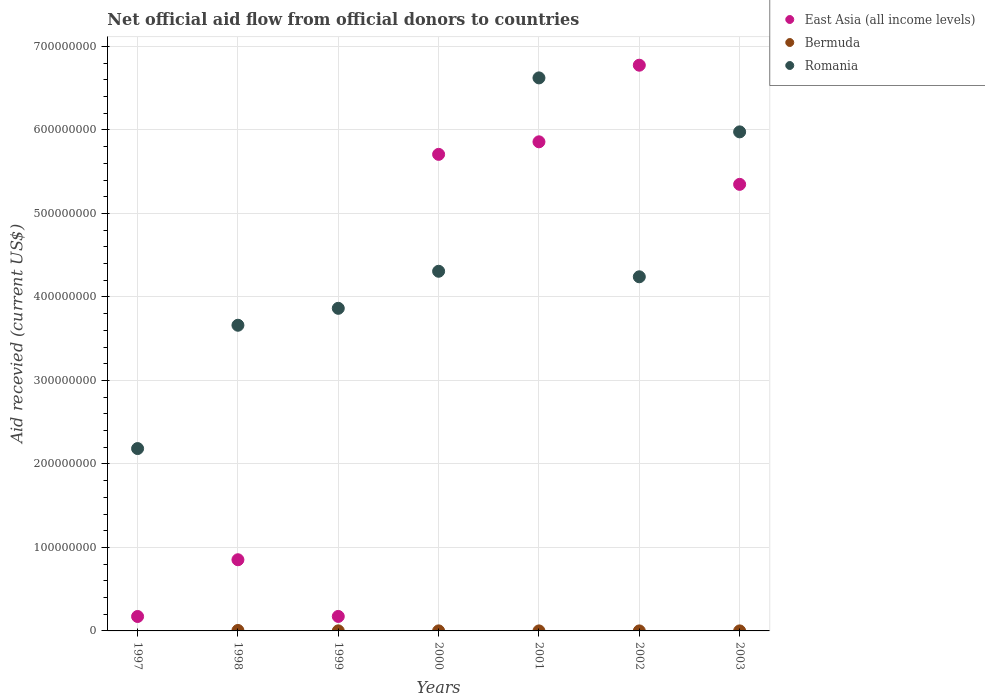Is the number of dotlines equal to the number of legend labels?
Give a very brief answer. No. What is the total aid received in Romania in 1999?
Make the answer very short. 3.86e+08. Across all years, what is the maximum total aid received in East Asia (all income levels)?
Ensure brevity in your answer.  6.78e+08. Across all years, what is the minimum total aid received in East Asia (all income levels)?
Your response must be concise. 1.73e+07. In which year was the total aid received in East Asia (all income levels) maximum?
Make the answer very short. 2002. What is the total total aid received in Romania in the graph?
Make the answer very short. 3.09e+09. What is the difference between the total aid received in Romania in 1999 and that in 2003?
Offer a terse response. -2.11e+08. What is the difference between the total aid received in Bermuda in 2003 and the total aid received in East Asia (all income levels) in 2000?
Provide a succinct answer. -5.71e+08. What is the average total aid received in East Asia (all income levels) per year?
Your answer should be very brief. 3.56e+08. In the year 2003, what is the difference between the total aid received in East Asia (all income levels) and total aid received in Romania?
Your answer should be compact. -6.29e+07. In how many years, is the total aid received in East Asia (all income levels) greater than 620000000 US$?
Make the answer very short. 1. What is the ratio of the total aid received in Romania in 1997 to that in 2000?
Offer a very short reply. 0.51. Is the difference between the total aid received in East Asia (all income levels) in 1999 and 2003 greater than the difference between the total aid received in Romania in 1999 and 2003?
Offer a terse response. No. What is the difference between the highest and the second highest total aid received in Romania?
Your answer should be compact. 6.46e+07. What is the difference between the highest and the lowest total aid received in Romania?
Make the answer very short. 4.44e+08. In how many years, is the total aid received in East Asia (all income levels) greater than the average total aid received in East Asia (all income levels) taken over all years?
Offer a very short reply. 4. Is the total aid received in Bermuda strictly greater than the total aid received in Romania over the years?
Offer a very short reply. No. How many dotlines are there?
Keep it short and to the point. 3. How many years are there in the graph?
Offer a terse response. 7. Are the values on the major ticks of Y-axis written in scientific E-notation?
Keep it short and to the point. No. Does the graph contain any zero values?
Offer a terse response. Yes. Does the graph contain grids?
Your response must be concise. Yes. Where does the legend appear in the graph?
Provide a succinct answer. Top right. How many legend labels are there?
Make the answer very short. 3. How are the legend labels stacked?
Your response must be concise. Vertical. What is the title of the graph?
Your answer should be very brief. Net official aid flow from official donors to countries. What is the label or title of the Y-axis?
Your answer should be compact. Aid recevied (current US$). What is the Aid recevied (current US$) of East Asia (all income levels) in 1997?
Make the answer very short. 1.73e+07. What is the Aid recevied (current US$) in Romania in 1997?
Offer a terse response. 2.18e+08. What is the Aid recevied (current US$) of East Asia (all income levels) in 1998?
Your answer should be very brief. 8.52e+07. What is the Aid recevied (current US$) of Bermuda in 1998?
Keep it short and to the point. 5.50e+05. What is the Aid recevied (current US$) in Romania in 1998?
Give a very brief answer. 3.66e+08. What is the Aid recevied (current US$) in East Asia (all income levels) in 1999?
Offer a very short reply. 1.74e+07. What is the Aid recevied (current US$) of Bermuda in 1999?
Keep it short and to the point. 8.00e+04. What is the Aid recevied (current US$) in Romania in 1999?
Offer a terse response. 3.86e+08. What is the Aid recevied (current US$) of East Asia (all income levels) in 2000?
Make the answer very short. 5.71e+08. What is the Aid recevied (current US$) of Bermuda in 2000?
Make the answer very short. 6.00e+04. What is the Aid recevied (current US$) of Romania in 2000?
Provide a short and direct response. 4.31e+08. What is the Aid recevied (current US$) of East Asia (all income levels) in 2001?
Ensure brevity in your answer.  5.86e+08. What is the Aid recevied (current US$) in Bermuda in 2001?
Provide a succinct answer. 2.00e+04. What is the Aid recevied (current US$) in Romania in 2001?
Give a very brief answer. 6.62e+08. What is the Aid recevied (current US$) in East Asia (all income levels) in 2002?
Offer a terse response. 6.78e+08. What is the Aid recevied (current US$) in Bermuda in 2002?
Your answer should be compact. 2.00e+04. What is the Aid recevied (current US$) in Romania in 2002?
Provide a succinct answer. 4.24e+08. What is the Aid recevied (current US$) of East Asia (all income levels) in 2003?
Make the answer very short. 5.35e+08. What is the Aid recevied (current US$) in Bermuda in 2003?
Your answer should be very brief. 3.00e+04. What is the Aid recevied (current US$) of Romania in 2003?
Keep it short and to the point. 5.98e+08. Across all years, what is the maximum Aid recevied (current US$) of East Asia (all income levels)?
Provide a succinct answer. 6.78e+08. Across all years, what is the maximum Aid recevied (current US$) in Romania?
Give a very brief answer. 6.62e+08. Across all years, what is the minimum Aid recevied (current US$) in East Asia (all income levels)?
Your answer should be very brief. 1.73e+07. Across all years, what is the minimum Aid recevied (current US$) in Bermuda?
Your answer should be very brief. 0. Across all years, what is the minimum Aid recevied (current US$) of Romania?
Your answer should be very brief. 2.18e+08. What is the total Aid recevied (current US$) in East Asia (all income levels) in the graph?
Give a very brief answer. 2.49e+09. What is the total Aid recevied (current US$) in Bermuda in the graph?
Offer a very short reply. 7.60e+05. What is the total Aid recevied (current US$) in Romania in the graph?
Keep it short and to the point. 3.09e+09. What is the difference between the Aid recevied (current US$) in East Asia (all income levels) in 1997 and that in 1998?
Provide a succinct answer. -6.80e+07. What is the difference between the Aid recevied (current US$) of Romania in 1997 and that in 1998?
Provide a short and direct response. -1.48e+08. What is the difference between the Aid recevied (current US$) of East Asia (all income levels) in 1997 and that in 1999?
Offer a terse response. -6.00e+04. What is the difference between the Aid recevied (current US$) of Romania in 1997 and that in 1999?
Offer a very short reply. -1.68e+08. What is the difference between the Aid recevied (current US$) in East Asia (all income levels) in 1997 and that in 2000?
Your answer should be very brief. -5.54e+08. What is the difference between the Aid recevied (current US$) in Romania in 1997 and that in 2000?
Give a very brief answer. -2.12e+08. What is the difference between the Aid recevied (current US$) in East Asia (all income levels) in 1997 and that in 2001?
Your response must be concise. -5.69e+08. What is the difference between the Aid recevied (current US$) in Romania in 1997 and that in 2001?
Offer a terse response. -4.44e+08. What is the difference between the Aid recevied (current US$) in East Asia (all income levels) in 1997 and that in 2002?
Keep it short and to the point. -6.60e+08. What is the difference between the Aid recevied (current US$) in Romania in 1997 and that in 2002?
Provide a short and direct response. -2.06e+08. What is the difference between the Aid recevied (current US$) of East Asia (all income levels) in 1997 and that in 2003?
Your response must be concise. -5.18e+08. What is the difference between the Aid recevied (current US$) of Romania in 1997 and that in 2003?
Offer a terse response. -3.79e+08. What is the difference between the Aid recevied (current US$) of East Asia (all income levels) in 1998 and that in 1999?
Provide a short and direct response. 6.79e+07. What is the difference between the Aid recevied (current US$) of Romania in 1998 and that in 1999?
Give a very brief answer. -2.03e+07. What is the difference between the Aid recevied (current US$) of East Asia (all income levels) in 1998 and that in 2000?
Make the answer very short. -4.86e+08. What is the difference between the Aid recevied (current US$) in Bermuda in 1998 and that in 2000?
Offer a terse response. 4.90e+05. What is the difference between the Aid recevied (current US$) of Romania in 1998 and that in 2000?
Ensure brevity in your answer.  -6.46e+07. What is the difference between the Aid recevied (current US$) of East Asia (all income levels) in 1998 and that in 2001?
Ensure brevity in your answer.  -5.01e+08. What is the difference between the Aid recevied (current US$) of Bermuda in 1998 and that in 2001?
Your answer should be very brief. 5.30e+05. What is the difference between the Aid recevied (current US$) in Romania in 1998 and that in 2001?
Offer a terse response. -2.96e+08. What is the difference between the Aid recevied (current US$) of East Asia (all income levels) in 1998 and that in 2002?
Ensure brevity in your answer.  -5.92e+08. What is the difference between the Aid recevied (current US$) in Bermuda in 1998 and that in 2002?
Provide a succinct answer. 5.30e+05. What is the difference between the Aid recevied (current US$) of Romania in 1998 and that in 2002?
Make the answer very short. -5.80e+07. What is the difference between the Aid recevied (current US$) in East Asia (all income levels) in 1998 and that in 2003?
Your response must be concise. -4.50e+08. What is the difference between the Aid recevied (current US$) in Bermuda in 1998 and that in 2003?
Offer a terse response. 5.20e+05. What is the difference between the Aid recevied (current US$) in Romania in 1998 and that in 2003?
Provide a succinct answer. -2.32e+08. What is the difference between the Aid recevied (current US$) of East Asia (all income levels) in 1999 and that in 2000?
Keep it short and to the point. -5.53e+08. What is the difference between the Aid recevied (current US$) in Romania in 1999 and that in 2000?
Ensure brevity in your answer.  -4.44e+07. What is the difference between the Aid recevied (current US$) of East Asia (all income levels) in 1999 and that in 2001?
Your response must be concise. -5.68e+08. What is the difference between the Aid recevied (current US$) of Bermuda in 1999 and that in 2001?
Your answer should be compact. 6.00e+04. What is the difference between the Aid recevied (current US$) in Romania in 1999 and that in 2001?
Your answer should be very brief. -2.76e+08. What is the difference between the Aid recevied (current US$) in East Asia (all income levels) in 1999 and that in 2002?
Your response must be concise. -6.60e+08. What is the difference between the Aid recevied (current US$) of Romania in 1999 and that in 2002?
Provide a succinct answer. -3.78e+07. What is the difference between the Aid recevied (current US$) in East Asia (all income levels) in 1999 and that in 2003?
Offer a very short reply. -5.18e+08. What is the difference between the Aid recevied (current US$) in Bermuda in 1999 and that in 2003?
Your answer should be compact. 5.00e+04. What is the difference between the Aid recevied (current US$) of Romania in 1999 and that in 2003?
Provide a succinct answer. -2.11e+08. What is the difference between the Aid recevied (current US$) in East Asia (all income levels) in 2000 and that in 2001?
Provide a short and direct response. -1.50e+07. What is the difference between the Aid recevied (current US$) of Bermuda in 2000 and that in 2001?
Ensure brevity in your answer.  4.00e+04. What is the difference between the Aid recevied (current US$) of Romania in 2000 and that in 2001?
Keep it short and to the point. -2.32e+08. What is the difference between the Aid recevied (current US$) of East Asia (all income levels) in 2000 and that in 2002?
Offer a very short reply. -1.07e+08. What is the difference between the Aid recevied (current US$) of Romania in 2000 and that in 2002?
Provide a succinct answer. 6.62e+06. What is the difference between the Aid recevied (current US$) of East Asia (all income levels) in 2000 and that in 2003?
Ensure brevity in your answer.  3.59e+07. What is the difference between the Aid recevied (current US$) in Bermuda in 2000 and that in 2003?
Make the answer very short. 3.00e+04. What is the difference between the Aid recevied (current US$) in Romania in 2000 and that in 2003?
Your response must be concise. -1.67e+08. What is the difference between the Aid recevied (current US$) in East Asia (all income levels) in 2001 and that in 2002?
Your answer should be very brief. -9.18e+07. What is the difference between the Aid recevied (current US$) in Bermuda in 2001 and that in 2002?
Provide a short and direct response. 0. What is the difference between the Aid recevied (current US$) in Romania in 2001 and that in 2002?
Your answer should be very brief. 2.38e+08. What is the difference between the Aid recevied (current US$) of East Asia (all income levels) in 2001 and that in 2003?
Give a very brief answer. 5.10e+07. What is the difference between the Aid recevied (current US$) in Bermuda in 2001 and that in 2003?
Your answer should be compact. -10000. What is the difference between the Aid recevied (current US$) in Romania in 2001 and that in 2003?
Your answer should be compact. 6.46e+07. What is the difference between the Aid recevied (current US$) of East Asia (all income levels) in 2002 and that in 2003?
Offer a terse response. 1.43e+08. What is the difference between the Aid recevied (current US$) in Romania in 2002 and that in 2003?
Provide a succinct answer. -1.74e+08. What is the difference between the Aid recevied (current US$) of East Asia (all income levels) in 1997 and the Aid recevied (current US$) of Bermuda in 1998?
Make the answer very short. 1.67e+07. What is the difference between the Aid recevied (current US$) in East Asia (all income levels) in 1997 and the Aid recevied (current US$) in Romania in 1998?
Your response must be concise. -3.49e+08. What is the difference between the Aid recevied (current US$) of East Asia (all income levels) in 1997 and the Aid recevied (current US$) of Bermuda in 1999?
Your answer should be very brief. 1.72e+07. What is the difference between the Aid recevied (current US$) in East Asia (all income levels) in 1997 and the Aid recevied (current US$) in Romania in 1999?
Make the answer very short. -3.69e+08. What is the difference between the Aid recevied (current US$) of East Asia (all income levels) in 1997 and the Aid recevied (current US$) of Bermuda in 2000?
Ensure brevity in your answer.  1.72e+07. What is the difference between the Aid recevied (current US$) in East Asia (all income levels) in 1997 and the Aid recevied (current US$) in Romania in 2000?
Your response must be concise. -4.13e+08. What is the difference between the Aid recevied (current US$) of East Asia (all income levels) in 1997 and the Aid recevied (current US$) of Bermuda in 2001?
Offer a terse response. 1.73e+07. What is the difference between the Aid recevied (current US$) of East Asia (all income levels) in 1997 and the Aid recevied (current US$) of Romania in 2001?
Your response must be concise. -6.45e+08. What is the difference between the Aid recevied (current US$) in East Asia (all income levels) in 1997 and the Aid recevied (current US$) in Bermuda in 2002?
Provide a short and direct response. 1.73e+07. What is the difference between the Aid recevied (current US$) in East Asia (all income levels) in 1997 and the Aid recevied (current US$) in Romania in 2002?
Your answer should be very brief. -4.07e+08. What is the difference between the Aid recevied (current US$) of East Asia (all income levels) in 1997 and the Aid recevied (current US$) of Bermuda in 2003?
Your answer should be very brief. 1.73e+07. What is the difference between the Aid recevied (current US$) of East Asia (all income levels) in 1997 and the Aid recevied (current US$) of Romania in 2003?
Your answer should be very brief. -5.80e+08. What is the difference between the Aid recevied (current US$) in East Asia (all income levels) in 1998 and the Aid recevied (current US$) in Bermuda in 1999?
Keep it short and to the point. 8.52e+07. What is the difference between the Aid recevied (current US$) of East Asia (all income levels) in 1998 and the Aid recevied (current US$) of Romania in 1999?
Provide a short and direct response. -3.01e+08. What is the difference between the Aid recevied (current US$) in Bermuda in 1998 and the Aid recevied (current US$) in Romania in 1999?
Ensure brevity in your answer.  -3.86e+08. What is the difference between the Aid recevied (current US$) in East Asia (all income levels) in 1998 and the Aid recevied (current US$) in Bermuda in 2000?
Offer a terse response. 8.52e+07. What is the difference between the Aid recevied (current US$) of East Asia (all income levels) in 1998 and the Aid recevied (current US$) of Romania in 2000?
Give a very brief answer. -3.46e+08. What is the difference between the Aid recevied (current US$) of Bermuda in 1998 and the Aid recevied (current US$) of Romania in 2000?
Keep it short and to the point. -4.30e+08. What is the difference between the Aid recevied (current US$) of East Asia (all income levels) in 1998 and the Aid recevied (current US$) of Bermuda in 2001?
Give a very brief answer. 8.52e+07. What is the difference between the Aid recevied (current US$) in East Asia (all income levels) in 1998 and the Aid recevied (current US$) in Romania in 2001?
Make the answer very short. -5.77e+08. What is the difference between the Aid recevied (current US$) of Bermuda in 1998 and the Aid recevied (current US$) of Romania in 2001?
Keep it short and to the point. -6.62e+08. What is the difference between the Aid recevied (current US$) of East Asia (all income levels) in 1998 and the Aid recevied (current US$) of Bermuda in 2002?
Offer a very short reply. 8.52e+07. What is the difference between the Aid recevied (current US$) of East Asia (all income levels) in 1998 and the Aid recevied (current US$) of Romania in 2002?
Keep it short and to the point. -3.39e+08. What is the difference between the Aid recevied (current US$) of Bermuda in 1998 and the Aid recevied (current US$) of Romania in 2002?
Offer a terse response. -4.24e+08. What is the difference between the Aid recevied (current US$) in East Asia (all income levels) in 1998 and the Aid recevied (current US$) in Bermuda in 2003?
Provide a succinct answer. 8.52e+07. What is the difference between the Aid recevied (current US$) of East Asia (all income levels) in 1998 and the Aid recevied (current US$) of Romania in 2003?
Give a very brief answer. -5.12e+08. What is the difference between the Aid recevied (current US$) in Bermuda in 1998 and the Aid recevied (current US$) in Romania in 2003?
Provide a succinct answer. -5.97e+08. What is the difference between the Aid recevied (current US$) of East Asia (all income levels) in 1999 and the Aid recevied (current US$) of Bermuda in 2000?
Offer a very short reply. 1.73e+07. What is the difference between the Aid recevied (current US$) in East Asia (all income levels) in 1999 and the Aid recevied (current US$) in Romania in 2000?
Offer a very short reply. -4.13e+08. What is the difference between the Aid recevied (current US$) of Bermuda in 1999 and the Aid recevied (current US$) of Romania in 2000?
Provide a short and direct response. -4.31e+08. What is the difference between the Aid recevied (current US$) of East Asia (all income levels) in 1999 and the Aid recevied (current US$) of Bermuda in 2001?
Make the answer very short. 1.73e+07. What is the difference between the Aid recevied (current US$) in East Asia (all income levels) in 1999 and the Aid recevied (current US$) in Romania in 2001?
Your answer should be compact. -6.45e+08. What is the difference between the Aid recevied (current US$) of Bermuda in 1999 and the Aid recevied (current US$) of Romania in 2001?
Your answer should be compact. -6.62e+08. What is the difference between the Aid recevied (current US$) of East Asia (all income levels) in 1999 and the Aid recevied (current US$) of Bermuda in 2002?
Give a very brief answer. 1.73e+07. What is the difference between the Aid recevied (current US$) in East Asia (all income levels) in 1999 and the Aid recevied (current US$) in Romania in 2002?
Give a very brief answer. -4.07e+08. What is the difference between the Aid recevied (current US$) in Bermuda in 1999 and the Aid recevied (current US$) in Romania in 2002?
Make the answer very short. -4.24e+08. What is the difference between the Aid recevied (current US$) in East Asia (all income levels) in 1999 and the Aid recevied (current US$) in Bermuda in 2003?
Keep it short and to the point. 1.73e+07. What is the difference between the Aid recevied (current US$) of East Asia (all income levels) in 1999 and the Aid recevied (current US$) of Romania in 2003?
Give a very brief answer. -5.80e+08. What is the difference between the Aid recevied (current US$) of Bermuda in 1999 and the Aid recevied (current US$) of Romania in 2003?
Offer a terse response. -5.98e+08. What is the difference between the Aid recevied (current US$) of East Asia (all income levels) in 2000 and the Aid recevied (current US$) of Bermuda in 2001?
Offer a terse response. 5.71e+08. What is the difference between the Aid recevied (current US$) of East Asia (all income levels) in 2000 and the Aid recevied (current US$) of Romania in 2001?
Offer a very short reply. -9.16e+07. What is the difference between the Aid recevied (current US$) of Bermuda in 2000 and the Aid recevied (current US$) of Romania in 2001?
Your answer should be compact. -6.62e+08. What is the difference between the Aid recevied (current US$) in East Asia (all income levels) in 2000 and the Aid recevied (current US$) in Bermuda in 2002?
Your answer should be compact. 5.71e+08. What is the difference between the Aid recevied (current US$) of East Asia (all income levels) in 2000 and the Aid recevied (current US$) of Romania in 2002?
Keep it short and to the point. 1.47e+08. What is the difference between the Aid recevied (current US$) in Bermuda in 2000 and the Aid recevied (current US$) in Romania in 2002?
Make the answer very short. -4.24e+08. What is the difference between the Aid recevied (current US$) of East Asia (all income levels) in 2000 and the Aid recevied (current US$) of Bermuda in 2003?
Keep it short and to the point. 5.71e+08. What is the difference between the Aid recevied (current US$) in East Asia (all income levels) in 2000 and the Aid recevied (current US$) in Romania in 2003?
Ensure brevity in your answer.  -2.69e+07. What is the difference between the Aid recevied (current US$) of Bermuda in 2000 and the Aid recevied (current US$) of Romania in 2003?
Provide a succinct answer. -5.98e+08. What is the difference between the Aid recevied (current US$) of East Asia (all income levels) in 2001 and the Aid recevied (current US$) of Bermuda in 2002?
Your response must be concise. 5.86e+08. What is the difference between the Aid recevied (current US$) in East Asia (all income levels) in 2001 and the Aid recevied (current US$) in Romania in 2002?
Provide a succinct answer. 1.62e+08. What is the difference between the Aid recevied (current US$) of Bermuda in 2001 and the Aid recevied (current US$) of Romania in 2002?
Provide a succinct answer. -4.24e+08. What is the difference between the Aid recevied (current US$) of East Asia (all income levels) in 2001 and the Aid recevied (current US$) of Bermuda in 2003?
Offer a very short reply. 5.86e+08. What is the difference between the Aid recevied (current US$) in East Asia (all income levels) in 2001 and the Aid recevied (current US$) in Romania in 2003?
Provide a succinct answer. -1.19e+07. What is the difference between the Aid recevied (current US$) in Bermuda in 2001 and the Aid recevied (current US$) in Romania in 2003?
Your answer should be compact. -5.98e+08. What is the difference between the Aid recevied (current US$) in East Asia (all income levels) in 2002 and the Aid recevied (current US$) in Bermuda in 2003?
Provide a succinct answer. 6.78e+08. What is the difference between the Aid recevied (current US$) in East Asia (all income levels) in 2002 and the Aid recevied (current US$) in Romania in 2003?
Provide a succinct answer. 7.98e+07. What is the difference between the Aid recevied (current US$) of Bermuda in 2002 and the Aid recevied (current US$) of Romania in 2003?
Provide a succinct answer. -5.98e+08. What is the average Aid recevied (current US$) in East Asia (all income levels) per year?
Your response must be concise. 3.56e+08. What is the average Aid recevied (current US$) in Bermuda per year?
Ensure brevity in your answer.  1.09e+05. What is the average Aid recevied (current US$) of Romania per year?
Make the answer very short. 4.41e+08. In the year 1997, what is the difference between the Aid recevied (current US$) of East Asia (all income levels) and Aid recevied (current US$) of Romania?
Keep it short and to the point. -2.01e+08. In the year 1998, what is the difference between the Aid recevied (current US$) in East Asia (all income levels) and Aid recevied (current US$) in Bermuda?
Your answer should be compact. 8.47e+07. In the year 1998, what is the difference between the Aid recevied (current US$) in East Asia (all income levels) and Aid recevied (current US$) in Romania?
Offer a terse response. -2.81e+08. In the year 1998, what is the difference between the Aid recevied (current US$) of Bermuda and Aid recevied (current US$) of Romania?
Your answer should be compact. -3.66e+08. In the year 1999, what is the difference between the Aid recevied (current US$) of East Asia (all income levels) and Aid recevied (current US$) of Bermuda?
Keep it short and to the point. 1.73e+07. In the year 1999, what is the difference between the Aid recevied (current US$) of East Asia (all income levels) and Aid recevied (current US$) of Romania?
Your response must be concise. -3.69e+08. In the year 1999, what is the difference between the Aid recevied (current US$) of Bermuda and Aid recevied (current US$) of Romania?
Provide a succinct answer. -3.86e+08. In the year 2000, what is the difference between the Aid recevied (current US$) in East Asia (all income levels) and Aid recevied (current US$) in Bermuda?
Offer a terse response. 5.71e+08. In the year 2000, what is the difference between the Aid recevied (current US$) in East Asia (all income levels) and Aid recevied (current US$) in Romania?
Give a very brief answer. 1.40e+08. In the year 2000, what is the difference between the Aid recevied (current US$) of Bermuda and Aid recevied (current US$) of Romania?
Your response must be concise. -4.31e+08. In the year 2001, what is the difference between the Aid recevied (current US$) in East Asia (all income levels) and Aid recevied (current US$) in Bermuda?
Keep it short and to the point. 5.86e+08. In the year 2001, what is the difference between the Aid recevied (current US$) in East Asia (all income levels) and Aid recevied (current US$) in Romania?
Keep it short and to the point. -7.66e+07. In the year 2001, what is the difference between the Aid recevied (current US$) in Bermuda and Aid recevied (current US$) in Romania?
Provide a succinct answer. -6.62e+08. In the year 2002, what is the difference between the Aid recevied (current US$) of East Asia (all income levels) and Aid recevied (current US$) of Bermuda?
Your answer should be very brief. 6.78e+08. In the year 2002, what is the difference between the Aid recevied (current US$) of East Asia (all income levels) and Aid recevied (current US$) of Romania?
Your answer should be compact. 2.53e+08. In the year 2002, what is the difference between the Aid recevied (current US$) of Bermuda and Aid recevied (current US$) of Romania?
Give a very brief answer. -4.24e+08. In the year 2003, what is the difference between the Aid recevied (current US$) of East Asia (all income levels) and Aid recevied (current US$) of Bermuda?
Provide a short and direct response. 5.35e+08. In the year 2003, what is the difference between the Aid recevied (current US$) in East Asia (all income levels) and Aid recevied (current US$) in Romania?
Make the answer very short. -6.29e+07. In the year 2003, what is the difference between the Aid recevied (current US$) in Bermuda and Aid recevied (current US$) in Romania?
Provide a succinct answer. -5.98e+08. What is the ratio of the Aid recevied (current US$) in East Asia (all income levels) in 1997 to that in 1998?
Make the answer very short. 0.2. What is the ratio of the Aid recevied (current US$) of Romania in 1997 to that in 1998?
Offer a terse response. 0.6. What is the ratio of the Aid recevied (current US$) of Romania in 1997 to that in 1999?
Offer a terse response. 0.57. What is the ratio of the Aid recevied (current US$) in East Asia (all income levels) in 1997 to that in 2000?
Provide a succinct answer. 0.03. What is the ratio of the Aid recevied (current US$) in Romania in 1997 to that in 2000?
Ensure brevity in your answer.  0.51. What is the ratio of the Aid recevied (current US$) in East Asia (all income levels) in 1997 to that in 2001?
Your answer should be very brief. 0.03. What is the ratio of the Aid recevied (current US$) of Romania in 1997 to that in 2001?
Your answer should be very brief. 0.33. What is the ratio of the Aid recevied (current US$) in East Asia (all income levels) in 1997 to that in 2002?
Make the answer very short. 0.03. What is the ratio of the Aid recevied (current US$) in Romania in 1997 to that in 2002?
Your answer should be very brief. 0.52. What is the ratio of the Aid recevied (current US$) of East Asia (all income levels) in 1997 to that in 2003?
Provide a short and direct response. 0.03. What is the ratio of the Aid recevied (current US$) of Romania in 1997 to that in 2003?
Ensure brevity in your answer.  0.37. What is the ratio of the Aid recevied (current US$) of East Asia (all income levels) in 1998 to that in 1999?
Your response must be concise. 4.91. What is the ratio of the Aid recevied (current US$) in Bermuda in 1998 to that in 1999?
Make the answer very short. 6.88. What is the ratio of the Aid recevied (current US$) of Romania in 1998 to that in 1999?
Provide a succinct answer. 0.95. What is the ratio of the Aid recevied (current US$) of East Asia (all income levels) in 1998 to that in 2000?
Your answer should be very brief. 0.15. What is the ratio of the Aid recevied (current US$) of Bermuda in 1998 to that in 2000?
Ensure brevity in your answer.  9.17. What is the ratio of the Aid recevied (current US$) of Romania in 1998 to that in 2000?
Give a very brief answer. 0.85. What is the ratio of the Aid recevied (current US$) of East Asia (all income levels) in 1998 to that in 2001?
Your answer should be compact. 0.15. What is the ratio of the Aid recevied (current US$) in Romania in 1998 to that in 2001?
Provide a succinct answer. 0.55. What is the ratio of the Aid recevied (current US$) of East Asia (all income levels) in 1998 to that in 2002?
Keep it short and to the point. 0.13. What is the ratio of the Aid recevied (current US$) in Romania in 1998 to that in 2002?
Provide a short and direct response. 0.86. What is the ratio of the Aid recevied (current US$) of East Asia (all income levels) in 1998 to that in 2003?
Your answer should be very brief. 0.16. What is the ratio of the Aid recevied (current US$) of Bermuda in 1998 to that in 2003?
Offer a terse response. 18.33. What is the ratio of the Aid recevied (current US$) in Romania in 1998 to that in 2003?
Your answer should be very brief. 0.61. What is the ratio of the Aid recevied (current US$) of East Asia (all income levels) in 1999 to that in 2000?
Make the answer very short. 0.03. What is the ratio of the Aid recevied (current US$) in Romania in 1999 to that in 2000?
Offer a very short reply. 0.9. What is the ratio of the Aid recevied (current US$) of East Asia (all income levels) in 1999 to that in 2001?
Your answer should be compact. 0.03. What is the ratio of the Aid recevied (current US$) in Bermuda in 1999 to that in 2001?
Ensure brevity in your answer.  4. What is the ratio of the Aid recevied (current US$) in Romania in 1999 to that in 2001?
Offer a very short reply. 0.58. What is the ratio of the Aid recevied (current US$) in East Asia (all income levels) in 1999 to that in 2002?
Your answer should be very brief. 0.03. What is the ratio of the Aid recevied (current US$) in Romania in 1999 to that in 2002?
Offer a terse response. 0.91. What is the ratio of the Aid recevied (current US$) in East Asia (all income levels) in 1999 to that in 2003?
Make the answer very short. 0.03. What is the ratio of the Aid recevied (current US$) in Bermuda in 1999 to that in 2003?
Provide a succinct answer. 2.67. What is the ratio of the Aid recevied (current US$) in Romania in 1999 to that in 2003?
Offer a very short reply. 0.65. What is the ratio of the Aid recevied (current US$) in East Asia (all income levels) in 2000 to that in 2001?
Your response must be concise. 0.97. What is the ratio of the Aid recevied (current US$) of Romania in 2000 to that in 2001?
Make the answer very short. 0.65. What is the ratio of the Aid recevied (current US$) of East Asia (all income levels) in 2000 to that in 2002?
Your response must be concise. 0.84. What is the ratio of the Aid recevied (current US$) in Bermuda in 2000 to that in 2002?
Provide a short and direct response. 3. What is the ratio of the Aid recevied (current US$) of Romania in 2000 to that in 2002?
Provide a short and direct response. 1.02. What is the ratio of the Aid recevied (current US$) of East Asia (all income levels) in 2000 to that in 2003?
Keep it short and to the point. 1.07. What is the ratio of the Aid recevied (current US$) of Romania in 2000 to that in 2003?
Keep it short and to the point. 0.72. What is the ratio of the Aid recevied (current US$) of East Asia (all income levels) in 2001 to that in 2002?
Your response must be concise. 0.86. What is the ratio of the Aid recevied (current US$) of Romania in 2001 to that in 2002?
Give a very brief answer. 1.56. What is the ratio of the Aid recevied (current US$) in East Asia (all income levels) in 2001 to that in 2003?
Make the answer very short. 1.1. What is the ratio of the Aid recevied (current US$) in Bermuda in 2001 to that in 2003?
Your answer should be compact. 0.67. What is the ratio of the Aid recevied (current US$) in Romania in 2001 to that in 2003?
Your answer should be compact. 1.11. What is the ratio of the Aid recevied (current US$) of East Asia (all income levels) in 2002 to that in 2003?
Offer a terse response. 1.27. What is the ratio of the Aid recevied (current US$) of Romania in 2002 to that in 2003?
Offer a very short reply. 0.71. What is the difference between the highest and the second highest Aid recevied (current US$) in East Asia (all income levels)?
Provide a succinct answer. 9.18e+07. What is the difference between the highest and the second highest Aid recevied (current US$) of Romania?
Offer a terse response. 6.46e+07. What is the difference between the highest and the lowest Aid recevied (current US$) of East Asia (all income levels)?
Your response must be concise. 6.60e+08. What is the difference between the highest and the lowest Aid recevied (current US$) in Bermuda?
Your answer should be compact. 5.50e+05. What is the difference between the highest and the lowest Aid recevied (current US$) in Romania?
Give a very brief answer. 4.44e+08. 